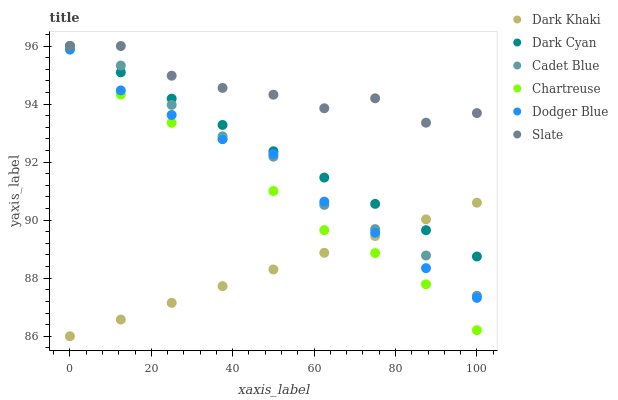Does Dark Khaki have the minimum area under the curve?
Answer yes or no. Yes. Does Slate have the maximum area under the curve?
Answer yes or no. Yes. Does Slate have the minimum area under the curve?
Answer yes or no. No. Does Dark Khaki have the maximum area under the curve?
Answer yes or no. No. Is Dark Khaki the smoothest?
Answer yes or no. Yes. Is Slate the roughest?
Answer yes or no. Yes. Is Slate the smoothest?
Answer yes or no. No. Is Dark Khaki the roughest?
Answer yes or no. No. Does Dark Khaki have the lowest value?
Answer yes or no. Yes. Does Slate have the lowest value?
Answer yes or no. No. Does Dark Cyan have the highest value?
Answer yes or no. Yes. Does Dark Khaki have the highest value?
Answer yes or no. No. Is Dodger Blue less than Dark Cyan?
Answer yes or no. Yes. Is Dark Cyan greater than Dodger Blue?
Answer yes or no. Yes. Does Dark Khaki intersect Dodger Blue?
Answer yes or no. Yes. Is Dark Khaki less than Dodger Blue?
Answer yes or no. No. Is Dark Khaki greater than Dodger Blue?
Answer yes or no. No. Does Dodger Blue intersect Dark Cyan?
Answer yes or no. No. 